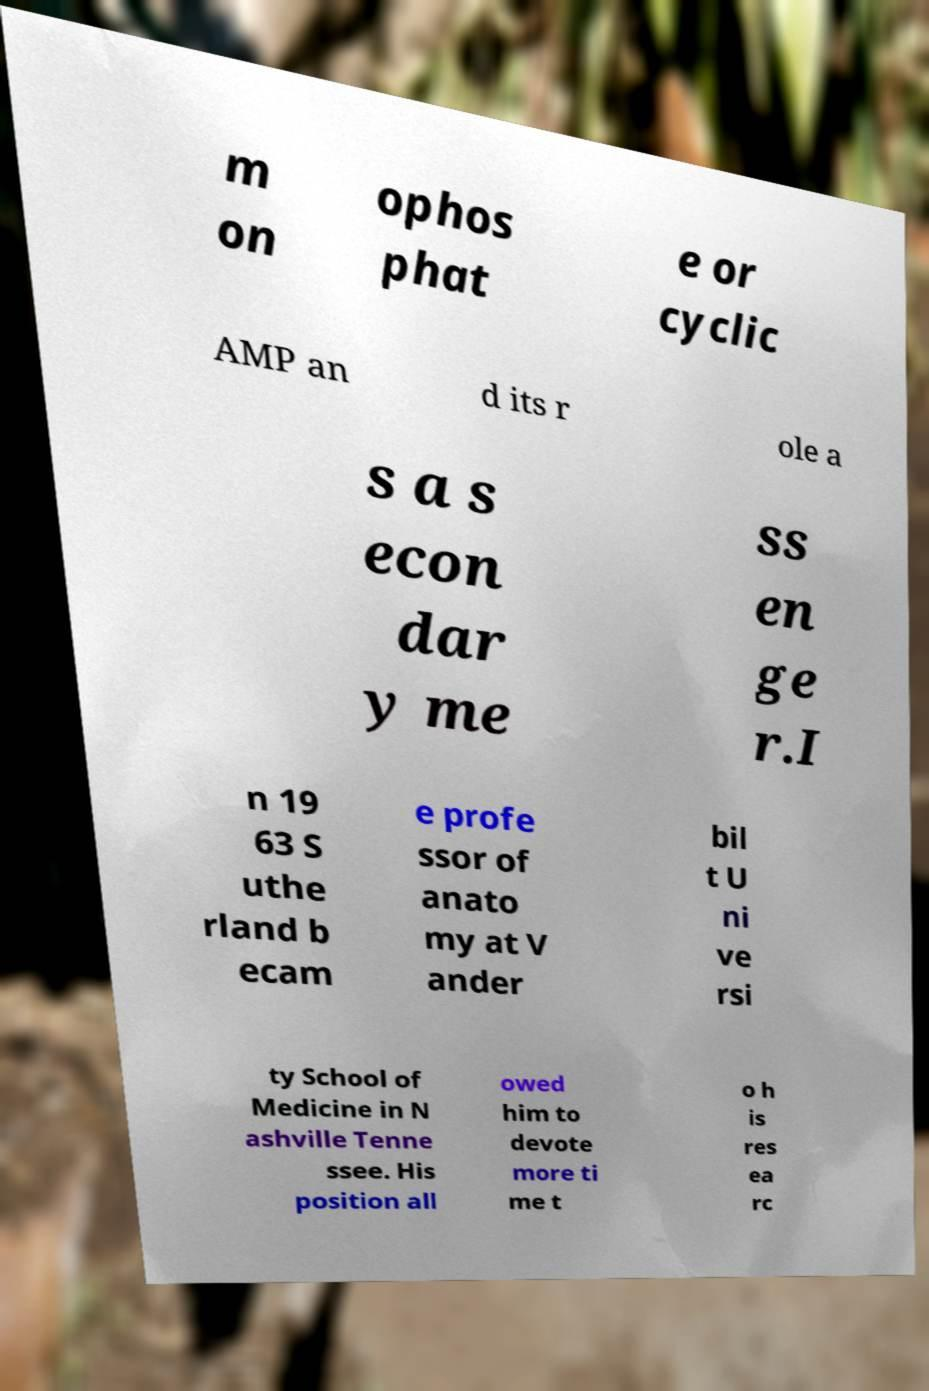Please read and relay the text visible in this image. What does it say? m on ophos phat e or cyclic AMP an d its r ole a s a s econ dar y me ss en ge r.I n 19 63 S uthe rland b ecam e profe ssor of anato my at V ander bil t U ni ve rsi ty School of Medicine in N ashville Tenne ssee. His position all owed him to devote more ti me t o h is res ea rc 